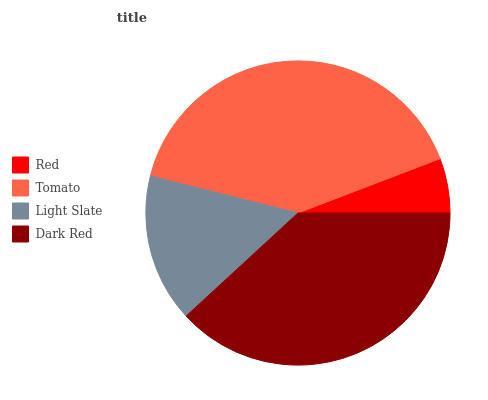Is Red the minimum?
Answer yes or no. Yes. Is Tomato the maximum?
Answer yes or no. Yes. Is Light Slate the minimum?
Answer yes or no. No. Is Light Slate the maximum?
Answer yes or no. No. Is Tomato greater than Light Slate?
Answer yes or no. Yes. Is Light Slate less than Tomato?
Answer yes or no. Yes. Is Light Slate greater than Tomato?
Answer yes or no. No. Is Tomato less than Light Slate?
Answer yes or no. No. Is Dark Red the high median?
Answer yes or no. Yes. Is Light Slate the low median?
Answer yes or no. Yes. Is Red the high median?
Answer yes or no. No. Is Dark Red the low median?
Answer yes or no. No. 